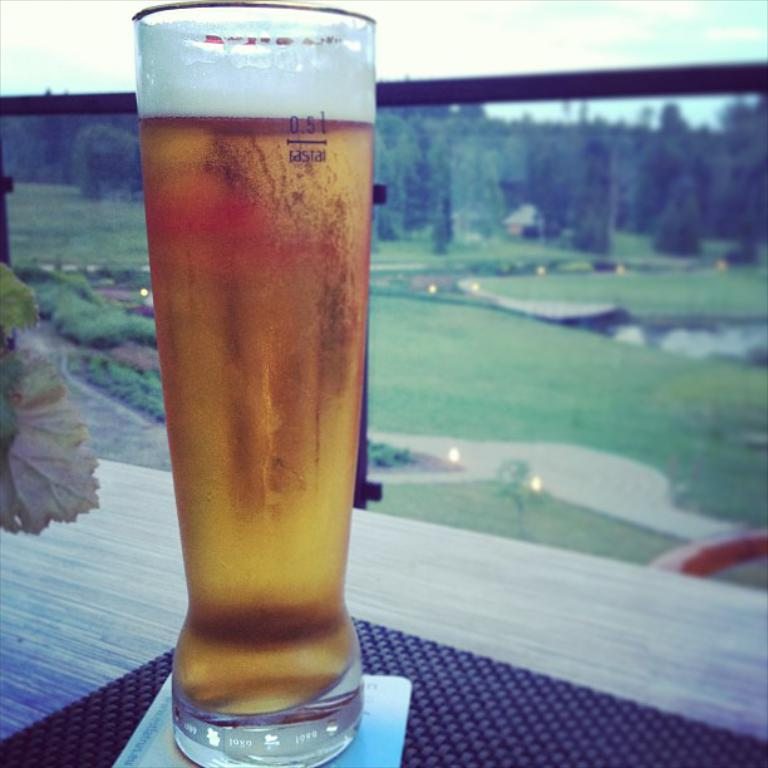What type of glass can be seen in the image? There is a wine glass in the image. What is the color of the grass in the image? The grass in the image is green. What type of vegetation is present in the image? There are trees in the image. What can be seen in the sky in the image? There are clouds visible in the sky. What type of growth can be seen on the trees in the image? There is no specific growth mentioned or visible on the trees in the image. --- Facts: 1. There is a person sitting on a bench in the image. 2. The person is reading a book. 3. There is a tree behind the bench. 4. The sky is visible in the image. Absurd Topics: parrot, dance, ocean Conversation: What is the person in the image doing? The person is sitting on a bench and reading a book. What is located behind the bench in the image? There is a tree behind the bench. What can be seen in the sky in the image? The sky is visible in the image. Reasoning: Let's think step by step in order to produce the conversation. We start by identifying the main subject in the image, which is the person sitting on the bench. Then, we expand the conversation to include the person's activity (reading a book) and the surrounding environment (the tree and the sky). Each question is designed to elicit a specific detail about the image that is known from the provided facts. Absurd Question/Answer: Can you see any parrots dancing near the ocean in the image? There are no parrots or dancing near the ocean in the image; it features a person sitting on a bench reading a book with a tree behind them and the sky visible. 